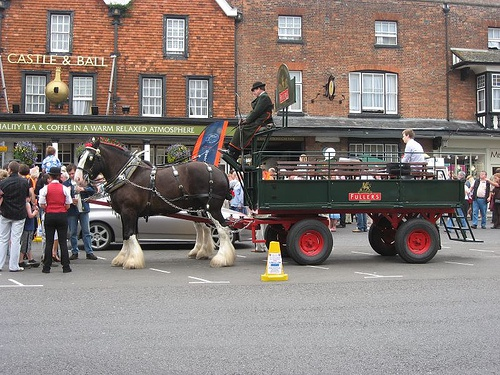Describe the objects in this image and their specific colors. I can see horse in black, gray, and darkgray tones, car in black, gray, darkgray, and white tones, people in black, white, gray, and brown tones, people in black, lavender, darkgray, and gray tones, and people in black, gray, maroon, and brown tones in this image. 